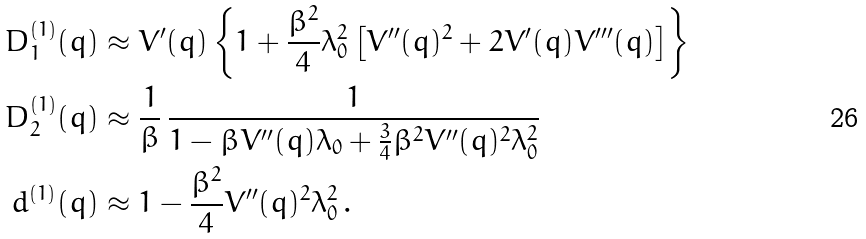Convert formula to latex. <formula><loc_0><loc_0><loc_500><loc_500>D _ { 1 } ^ { ( 1 ) } ( q ) & \approx V ^ { \prime } ( q ) \left \{ 1 + \frac { \beta ^ { 2 } } { 4 } \lambda _ { 0 } ^ { 2 } \left [ V ^ { \prime \prime } ( q ) ^ { 2 } + 2 V ^ { \prime } ( q ) V ^ { \prime \prime \prime } ( q ) \right ] \right \} \\ D _ { 2 } ^ { ( 1 ) } ( q ) & \approx \frac { 1 } { \beta } \, \frac { 1 } { 1 - \beta V ^ { \prime \prime } ( q ) \lambda _ { 0 } + \frac { 3 } { 4 } \beta ^ { 2 } V ^ { \prime \prime } ( q ) ^ { 2 } \lambda _ { 0 } ^ { 2 } } \\ d ^ { ( 1 ) } ( q ) & \approx 1 - \frac { \beta ^ { 2 } } { 4 } V ^ { \prime \prime } ( q ) ^ { 2 } \lambda _ { 0 } ^ { 2 } \, .</formula> 